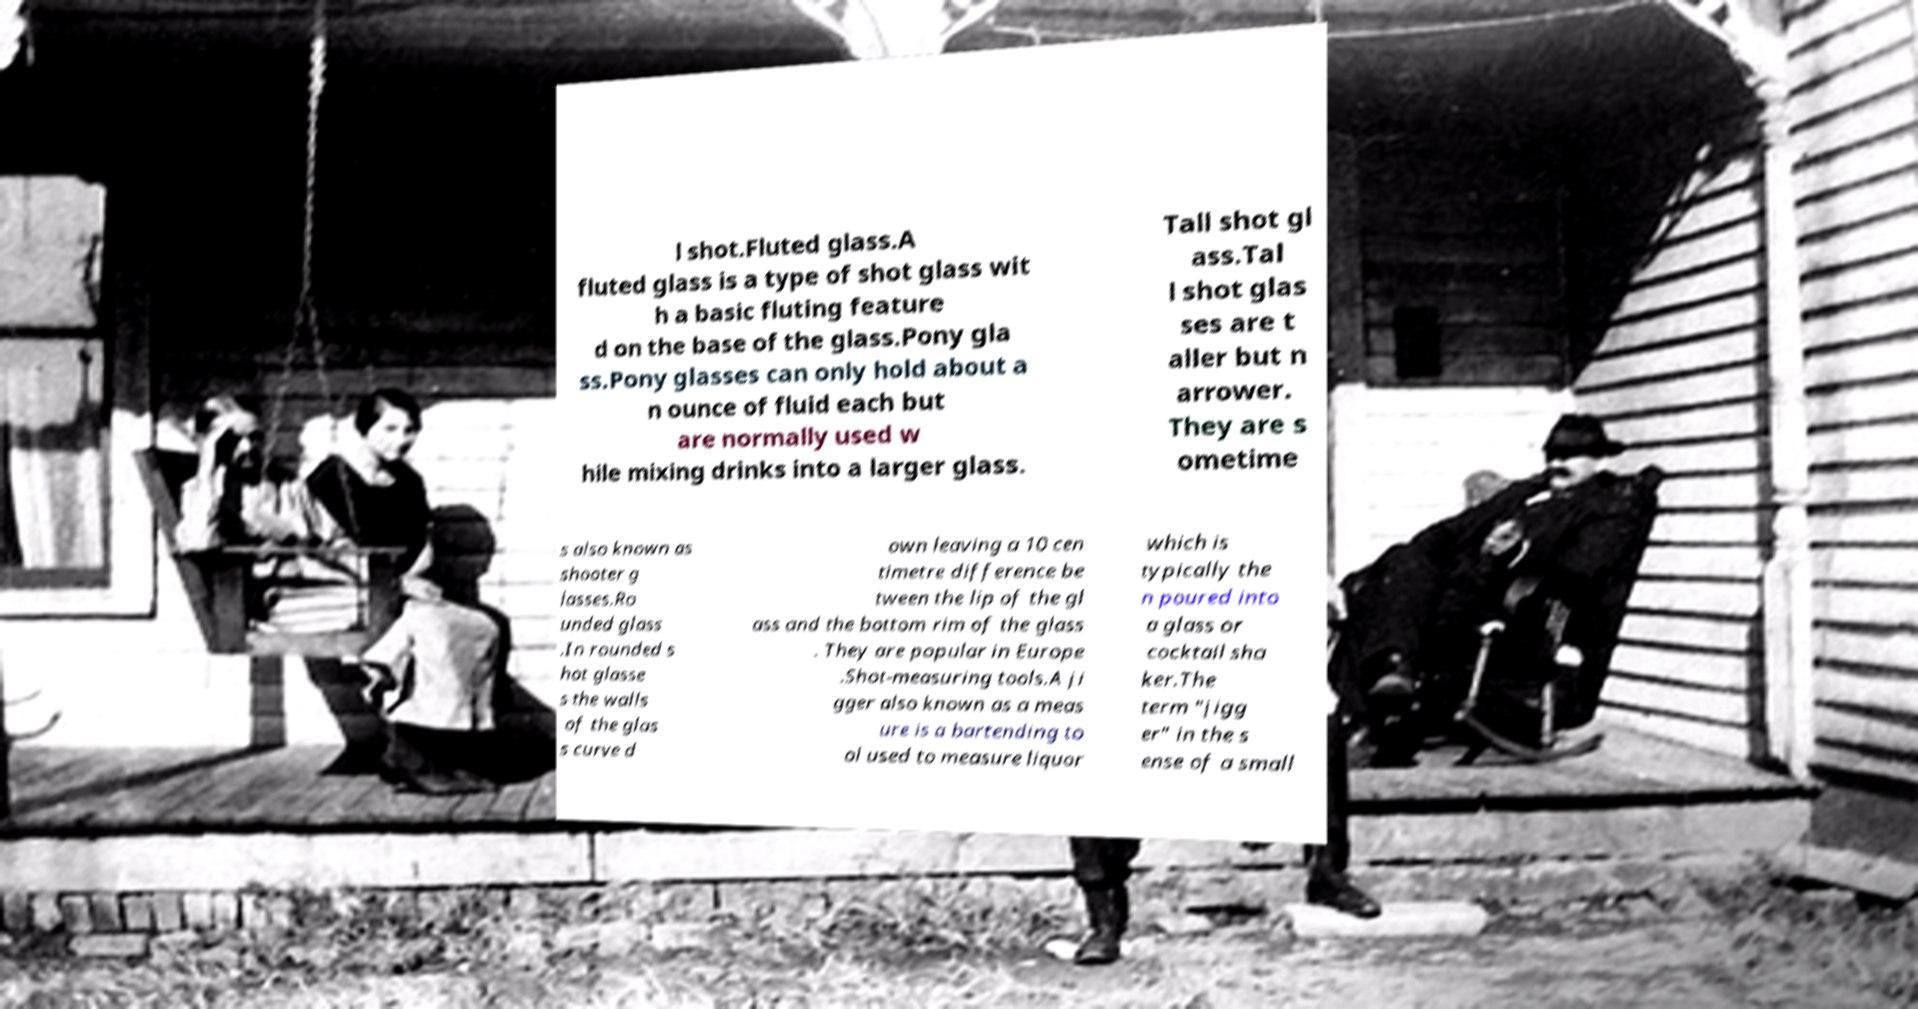Could you extract and type out the text from this image? l shot.Fluted glass.A fluted glass is a type of shot glass wit h a basic fluting feature d on the base of the glass.Pony gla ss.Pony glasses can only hold about a n ounce of fluid each but are normally used w hile mixing drinks into a larger glass. Tall shot gl ass.Tal l shot glas ses are t aller but n arrower. They are s ometime s also known as shooter g lasses.Ro unded glass .In rounded s hot glasse s the walls of the glas s curve d own leaving a 10 cen timetre difference be tween the lip of the gl ass and the bottom rim of the glass . They are popular in Europe .Shot-measuring tools.A ji gger also known as a meas ure is a bartending to ol used to measure liquor which is typically the n poured into a glass or cocktail sha ker.The term "jigg er" in the s ense of a small 